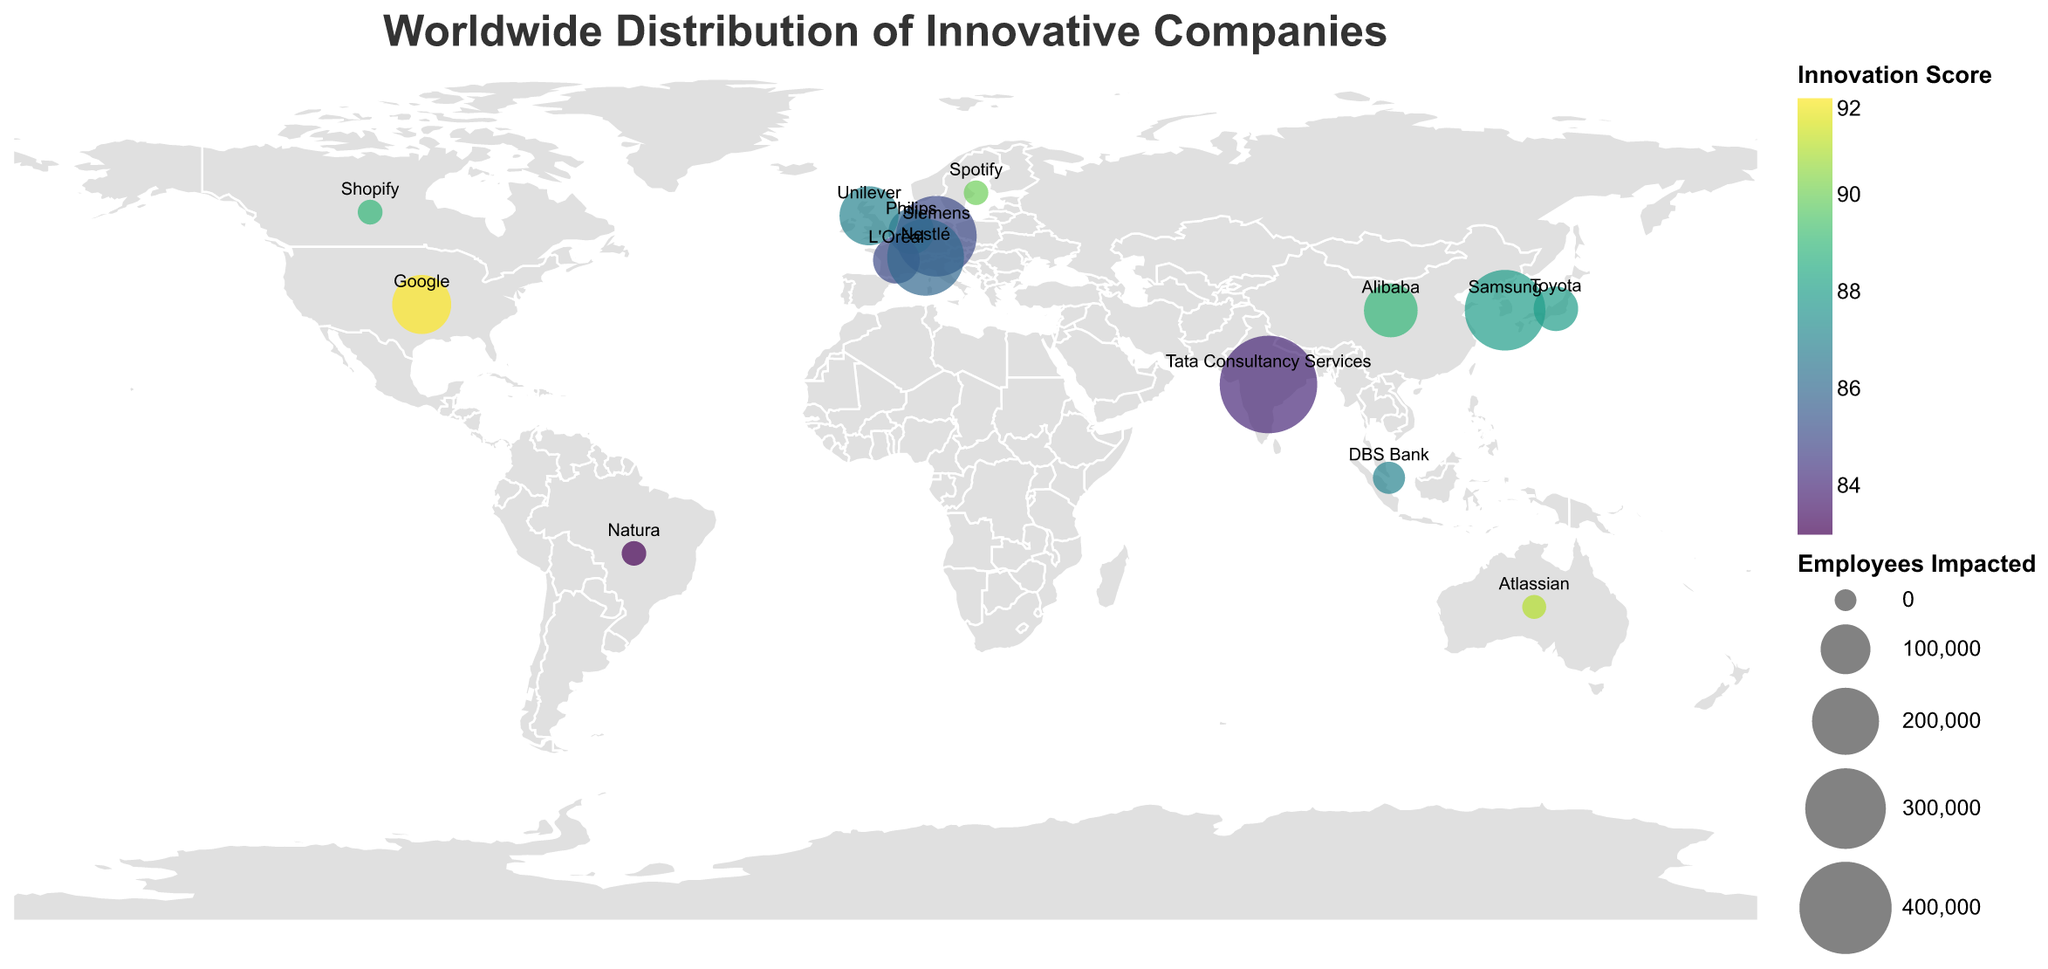What is the title of the figure? The title of the figure is typically displayed at the top and provides an overview of what the plot represents. In this case, the title "Worldwide Distribution of Innovative Companies" is clearly shown at the top of the plot.
Answer: "Worldwide Distribution of Innovative Companies" How many companies on the plot have an Innovation Score higher than 90? To determine this, we need to count the companies where the "Innovation Score" field is greater than 90. According to the data points and their color intensity, Google (92), Spotify (90), Shopify (89), and Alibaba (89) meet this criterion.
Answer: 4 Which company has the highest number of employees impacted? The size of the circles represents the number of employees impacted. By observing the largest circle on the plot, we can see that Tata Consultancy Services in India has the highest number of employees impacted with 450,000.
Answer: Tata Consultancy Services Which country has multiple companies displayed on the figure? By observing the labels of companies on the figure, you can see that most countries have one company, but none have multiple entries based on the provided data points.
Answer: None What is the average Innovation Score of all companies? To find the average Innovation Score, we sum all the Innovation Scores and divide by the number of companies. Calculating: (92 + 88 + 85 + 90 + 87 + 91 + 86 + 84 + 83 + 89 + 87 + 85 + 86 + 88 + 89) / 15 = 87.
Answer: 87 Which company has implemented strategies impacting the smallest number of employees? The size of the circles represents the number of employees impacted. By identifying the smallest circle on the plot, we see that Spotify in Sweden and Natura in Brazil both have the smallest number of employees impacted, with 6,500 employees each.
Answer: Spotify and Natura Which continent showcases the highest concentration of innovative companies? By observing the geographic distribution of the companies on the map, it is apparent that Europe (Germany, Sweden, Netherlands, United Kingdom, France, Switzerland) has the highest concentration of innovative companies.
Answer: Europe How does the Innovation Score of Alibaba compare to that of Siemens? Alibaba in China has an Innovation Score of 89, while Siemens in Germany has an Innovation Score of 85. Therefore, Alibaba's Innovation Score is higher than that of Siemens.
Answer: Alibaba is higher What is the combined total number of employees impacted by companies in Asia? To find this, we add the number of employees impacted by companies located in Asia: Toyota (Japan), DBS Bank (Singapore), Samsung (South Korea), and Alibaba (China). Calculating: 75,000 (Toyota) + 28,000 (DBS Bank) + 300,000 (Samsung) + 120,000 (Alibaba) = 523,000.
Answer: 523,000 Which company from North America has an Innovation Score closest to 90? By considering the companies from North America (Google, Shopify), we see Google has an Innovation Score of 92 and Shopify has an Innovation Score of 89. Shopify's score is closest to 90.
Answer: Shopify 